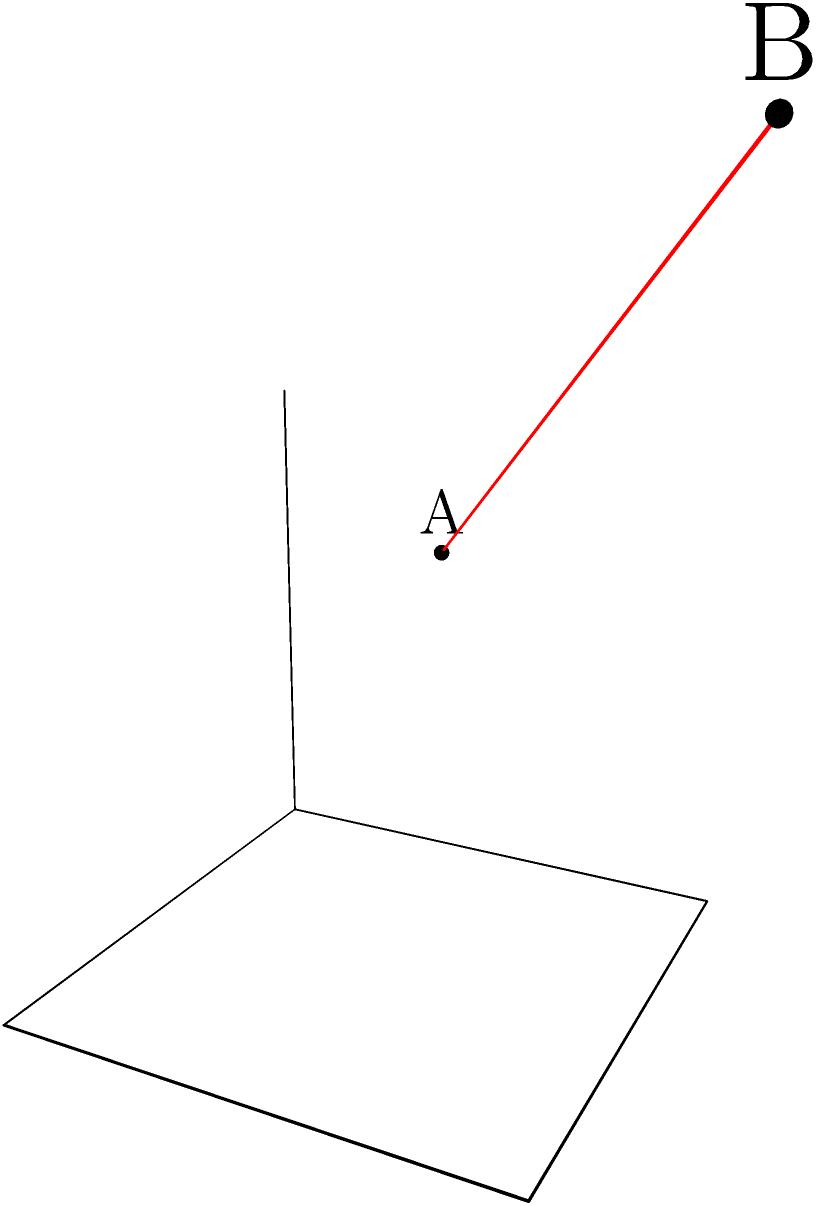Given two points $A(1,2,3)$ and $B(4,5,6)$ in a 3D coordinate system, calculate the distance between them. Round your answer to two decimal places. To find the distance between two points in a 3D coordinate system, we can use the distance formula:

$$d = \sqrt{(x_2-x_1)^2 + (y_2-y_1)^2 + (z_2-z_1)^2}$$

Where $(x_1,y_1,z_1)$ are the coordinates of point A and $(x_2,y_2,z_2)$ are the coordinates of point B.

Let's substitute the values:

1) $x_1 = 1$, $y_1 = 2$, $z_1 = 3$
2) $x_2 = 4$, $y_2 = 5$, $z_2 = 6$

Now, let's calculate each term inside the square root:

3) $(x_2-x_1)^2 = (4-1)^2 = 3^2 = 9$
4) $(y_2-y_1)^2 = (5-2)^2 = 3^2 = 9$
5) $(z_2-z_1)^2 = (6-3)^2 = 3^2 = 9$

6) Add these terms:
   $9 + 9 + 9 = 27$

7) Take the square root:
   $d = \sqrt{27} \approx 5.196152422706632$

8) Rounding to two decimal places:
   $d \approx 5.20$
Answer: 5.20 